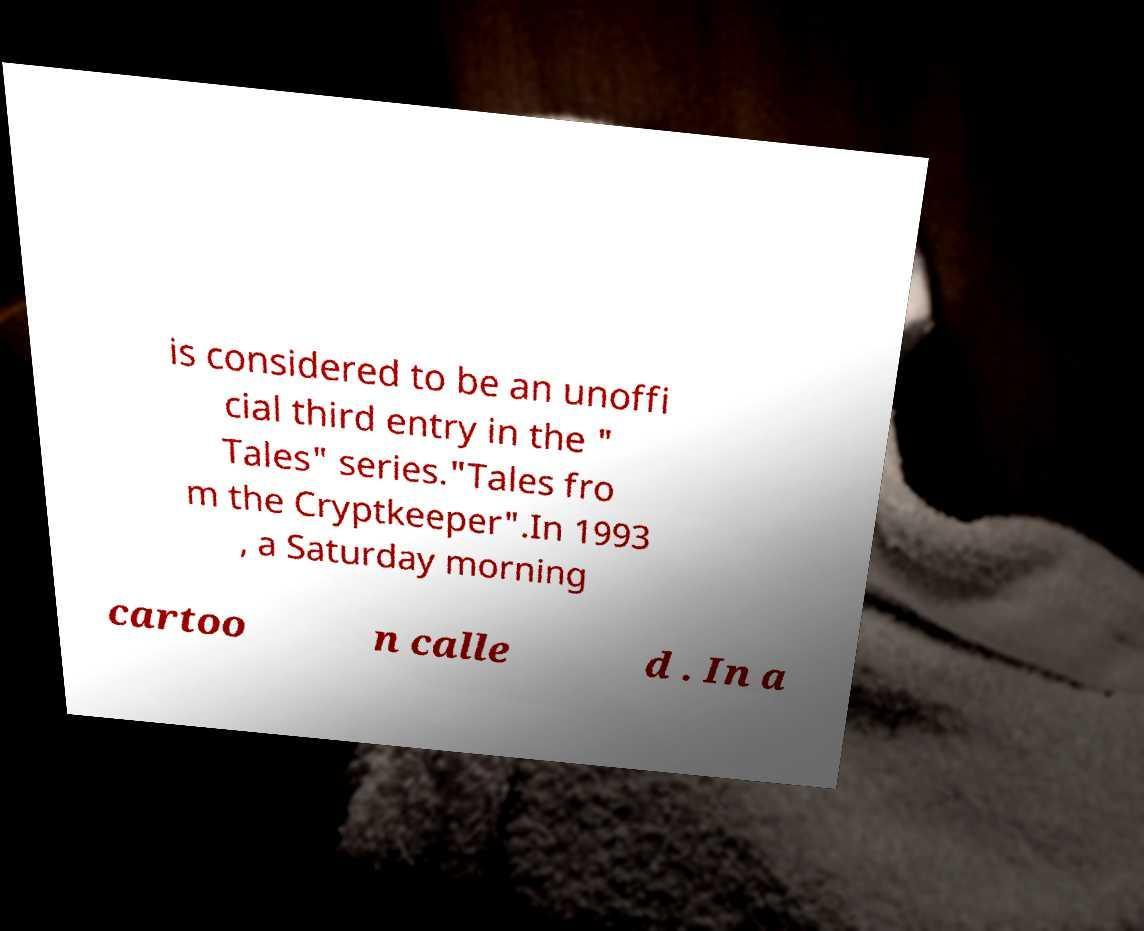Can you accurately transcribe the text from the provided image for me? is considered to be an unoffi cial third entry in the " Tales" series."Tales fro m the Cryptkeeper".In 1993 , a Saturday morning cartoo n calle d . In a 